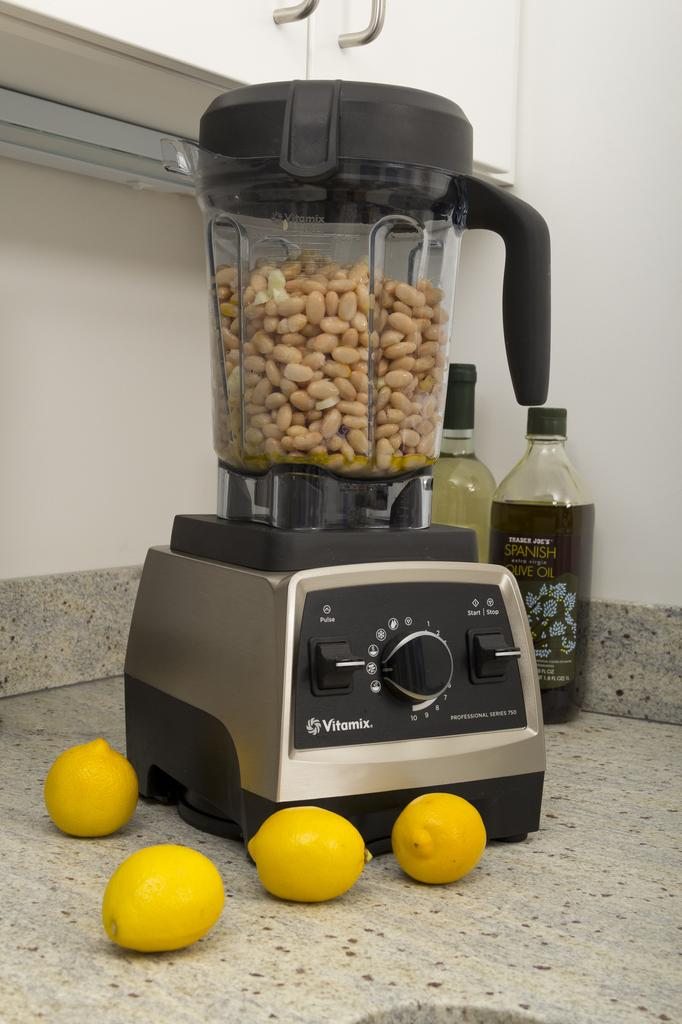<image>
Summarize the visual content of the image. a Vitamix blender on a counter full of peanuts 